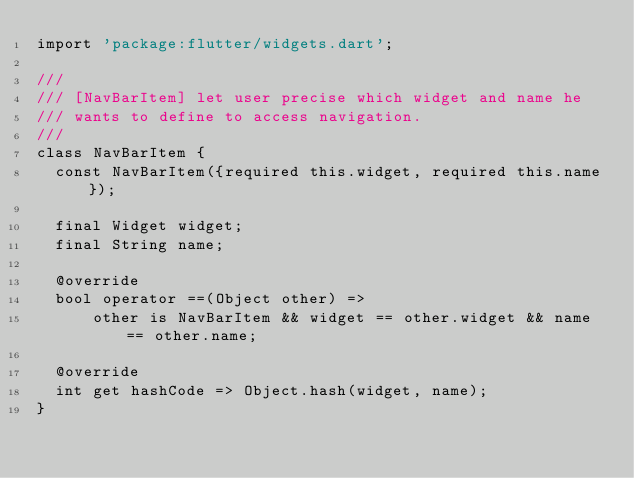<code> <loc_0><loc_0><loc_500><loc_500><_Dart_>import 'package:flutter/widgets.dart';

///
/// [NavBarItem] let user precise which widget and name he
/// wants to define to access navigation.
///
class NavBarItem {
  const NavBarItem({required this.widget, required this.name});

  final Widget widget;
  final String name;

  @override
  bool operator ==(Object other) =>
      other is NavBarItem && widget == other.widget && name == other.name;

  @override
  int get hashCode => Object.hash(widget, name);
}
</code> 